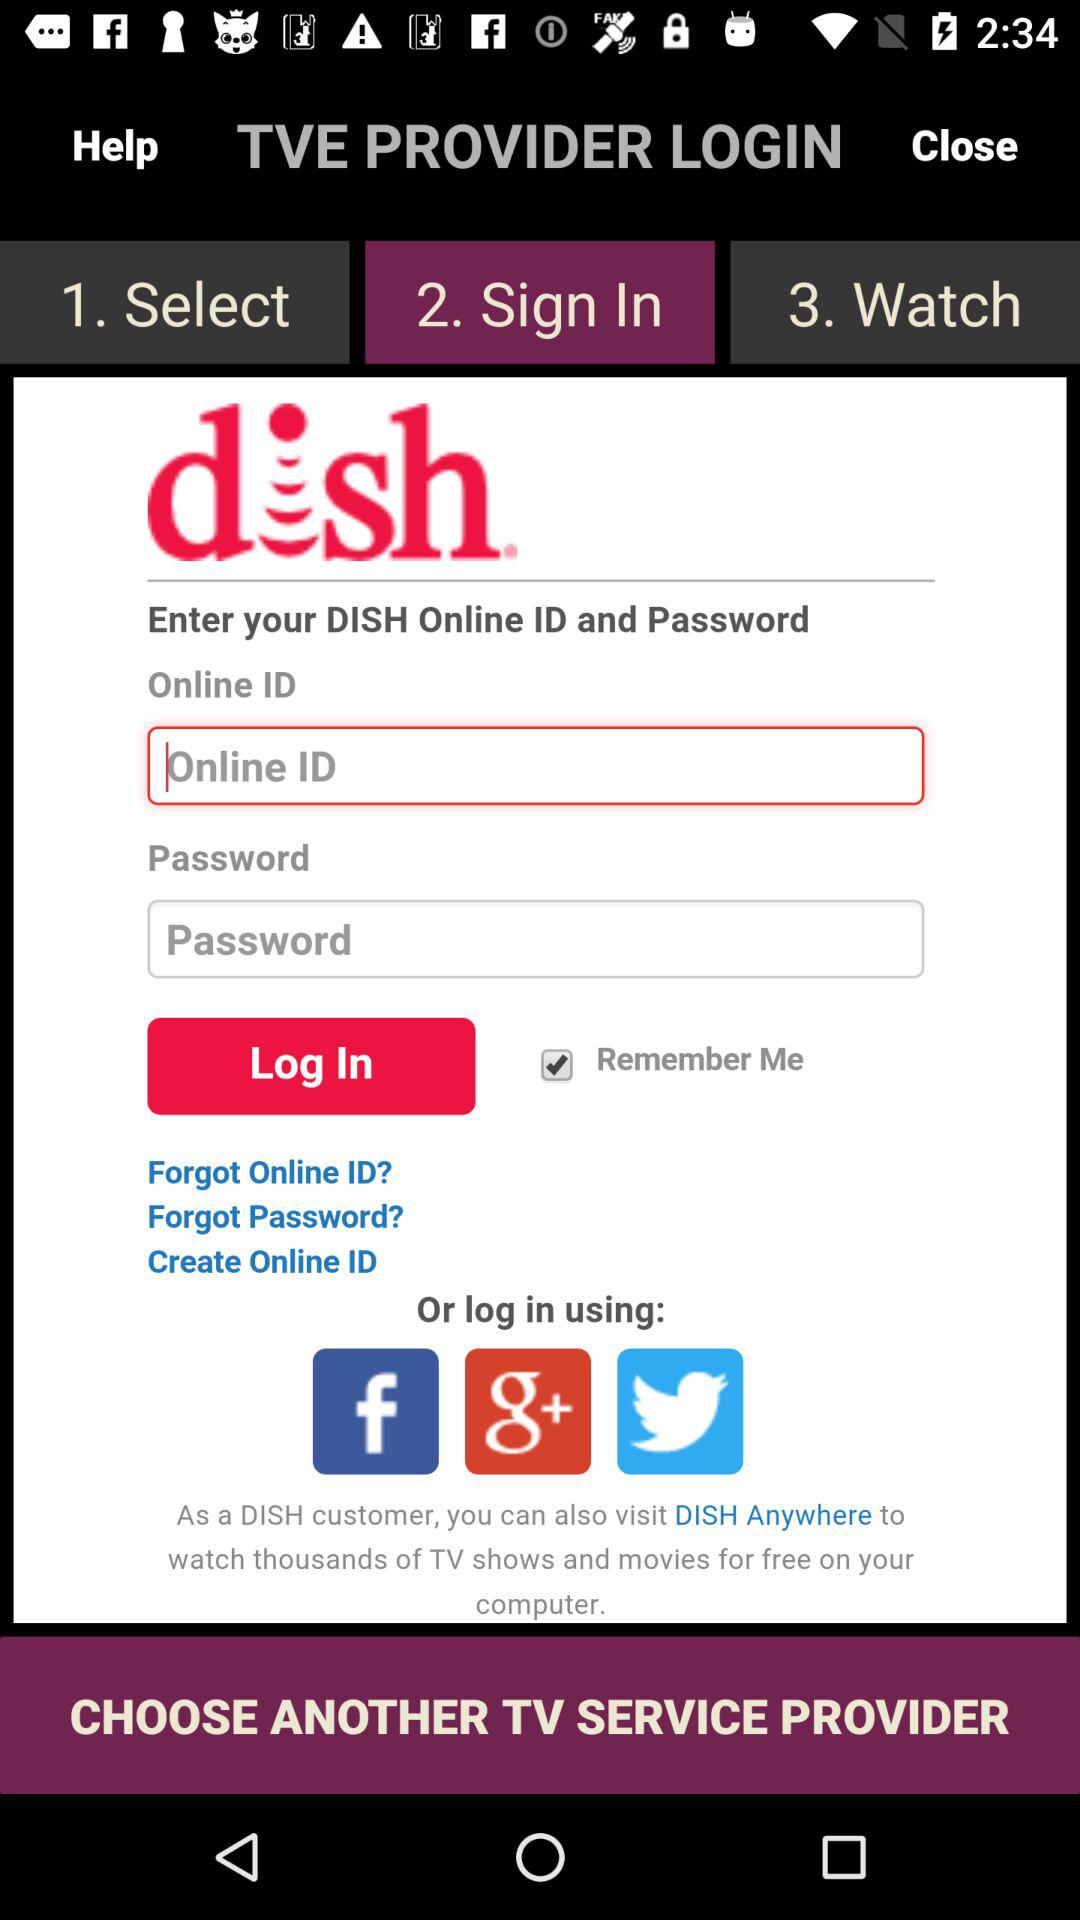Which option is selected? The selected option is "2. Sign In". 